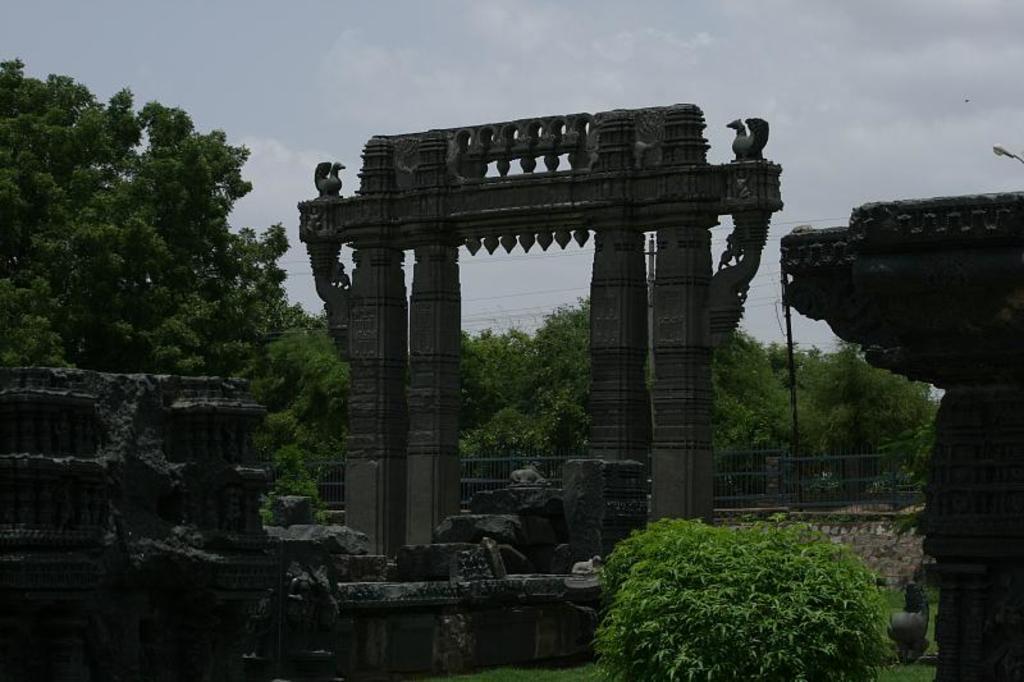How would you summarize this image in a sentence or two? In the picture we can see some grass surface with some plants on it and behind it, we can see some historical constructions and behind it, we can see, full of trees and behind it we can see a sky with clouds. 